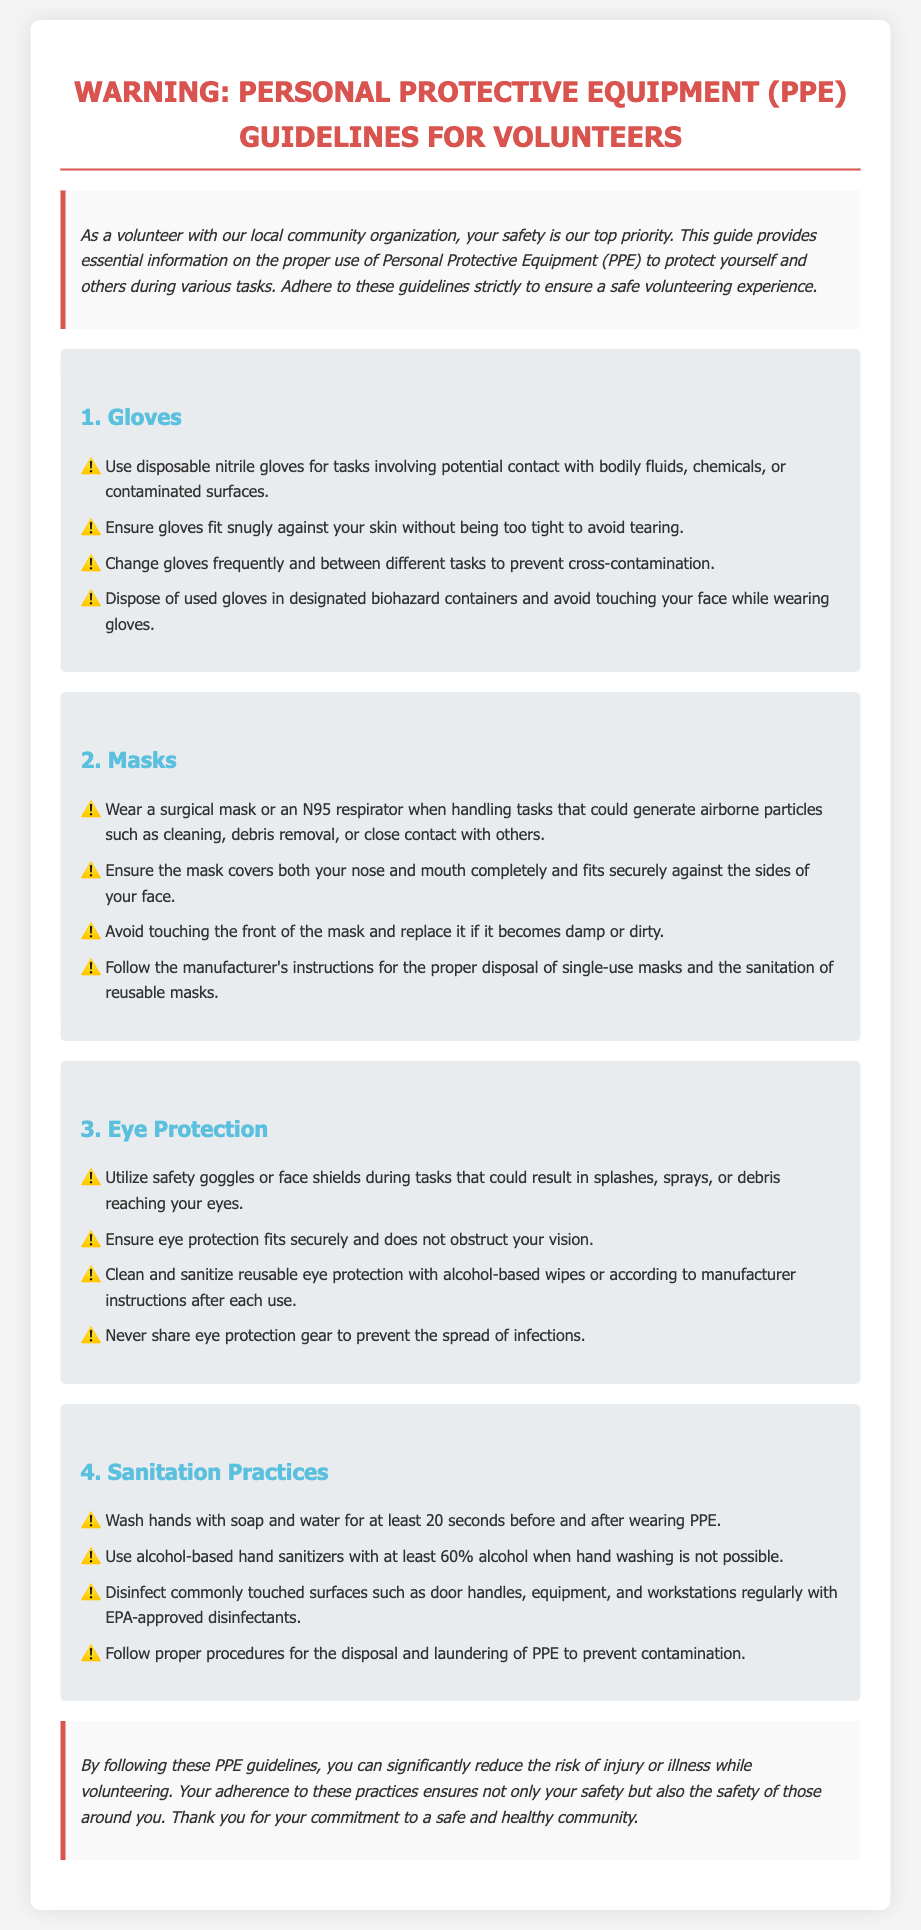What type of gloves should be used for tasks involving bodily fluids? The document specifies the use of disposable nitrile gloves for tasks involving potential contact with bodily fluids.
Answer: Disposable nitrile gloves How often should gloves be changed during tasks? The guidelines mention that gloves should be changed frequently and between different tasks to prevent cross-contamination.
Answer: Frequently When should a mask be worn? Masks should be worn when handling tasks that could generate airborne particles such as cleaning or debris removal.
Answer: Airborne particles What should be done with used gloves? Used gloves should be disposed of in designated biohazard containers to ensure proper sanitation.
Answer: Designated biohazard containers Which type of eye protection is recommended? The document recommends using safety goggles or face shields during tasks that could result in splashes or debris.
Answer: Safety goggles or face shields What is the minimum alcohol percentage for hand sanitizers? The document states that hand sanitizers should contain at least 60% alcohol when hand washing isn't possible.
Answer: 60% How long should hands be washed? The guidelines specify washing hands with soap and water for at least 20 seconds.
Answer: 20 seconds What should not be done while wearing gloves? The document advises against touching your face while wearing gloves to prevent contamination.
Answer: Touching face What should you do if a mask becomes damp? If a mask becomes damp or dirty, it should be replaced immediately to maintain protection.
Answer: Replace it 